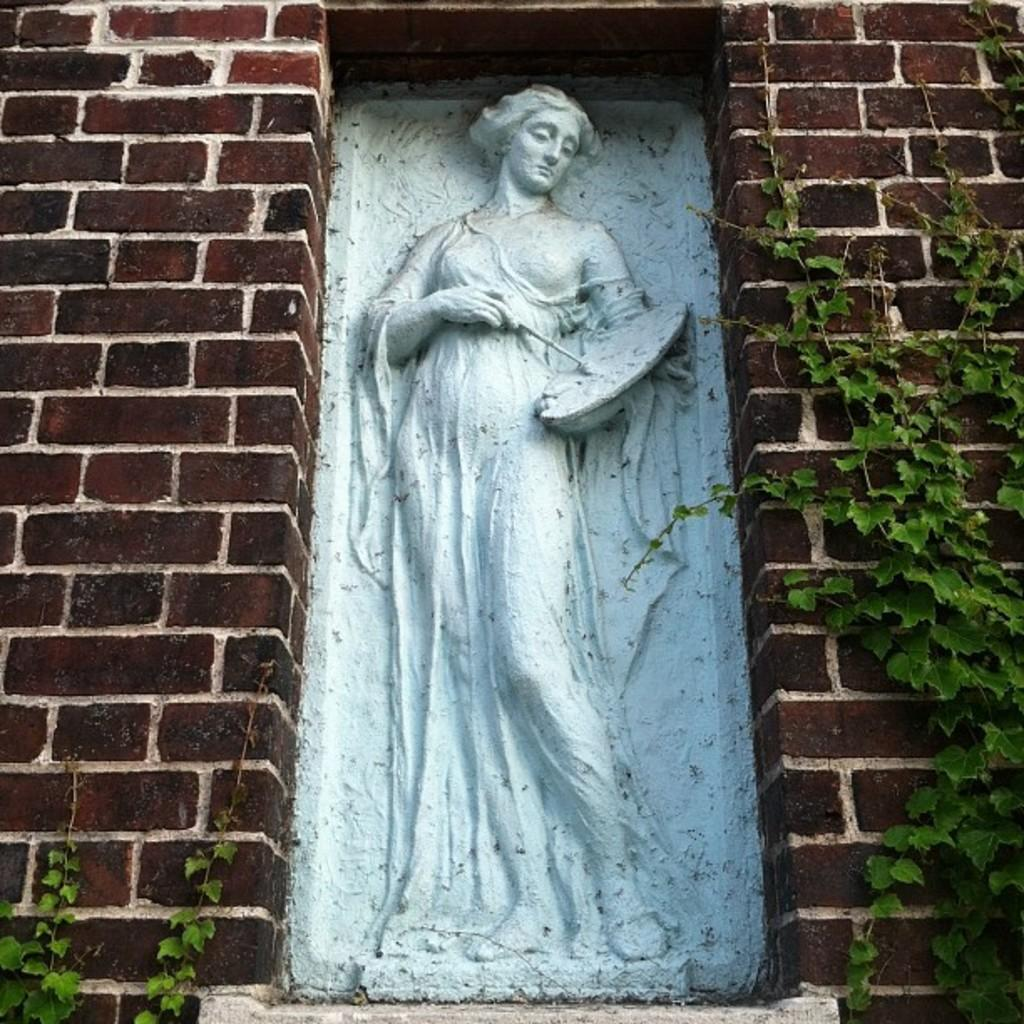What is the main subject in the image? There is a sculpture in the image. What is located behind the sculpture? There is a wall in the image. What type of living organism is present in the image? There is a plant in the image. Can you tell me how many friends are depicted in the sculpture? There is no depiction of friends in the sculpture; it is a standalone artwork. What type of spoon is being used by the person in the image? There is no person or spoon present in the image. 